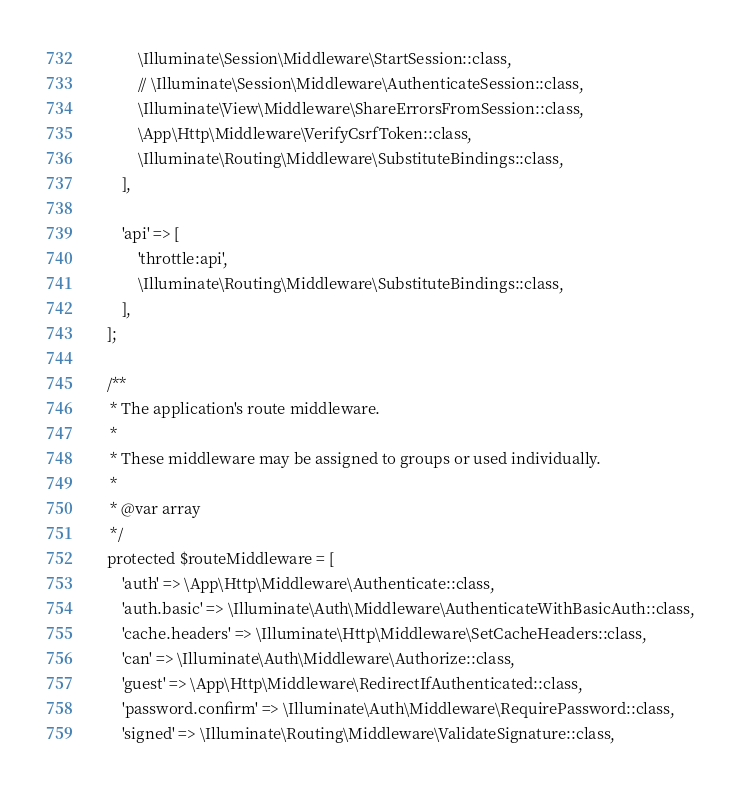Convert code to text. <code><loc_0><loc_0><loc_500><loc_500><_PHP_>            \Illuminate\Session\Middleware\StartSession::class,
            // \Illuminate\Session\Middleware\AuthenticateSession::class,
            \Illuminate\View\Middleware\ShareErrorsFromSession::class,
            \App\Http\Middleware\VerifyCsrfToken::class,
            \Illuminate\Routing\Middleware\SubstituteBindings::class,           
        ],

        'api' => [
            'throttle:api',
            \Illuminate\Routing\Middleware\SubstituteBindings::class,
        ],
    ];

    /**
     * The application's route middleware.
     *
     * These middleware may be assigned to groups or used individually.
     *
     * @var array
     */
    protected $routeMiddleware = [
        'auth' => \App\Http\Middleware\Authenticate::class,
        'auth.basic' => \Illuminate\Auth\Middleware\AuthenticateWithBasicAuth::class,
        'cache.headers' => \Illuminate\Http\Middleware\SetCacheHeaders::class,
        'can' => \Illuminate\Auth\Middleware\Authorize::class,
        'guest' => \App\Http\Middleware\RedirectIfAuthenticated::class,
        'password.confirm' => \Illuminate\Auth\Middleware\RequirePassword::class,
        'signed' => \Illuminate\Routing\Middleware\ValidateSignature::class,</code> 